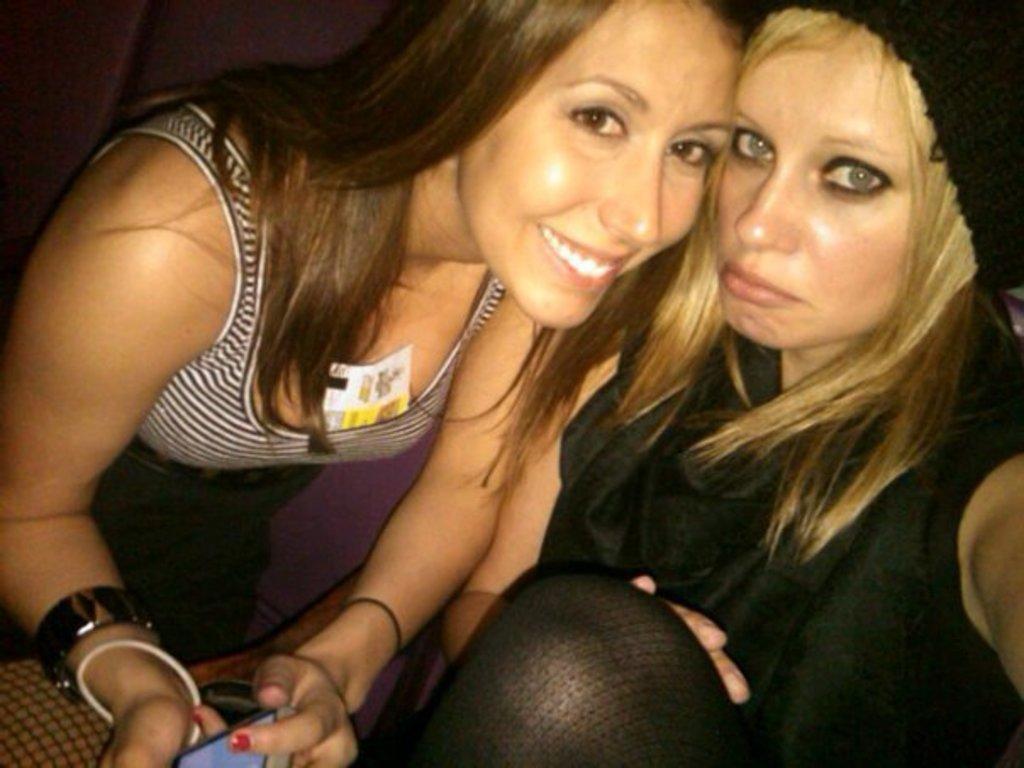Describe this image in one or two sentences. In this image, we can see two persons wearing clothes. 